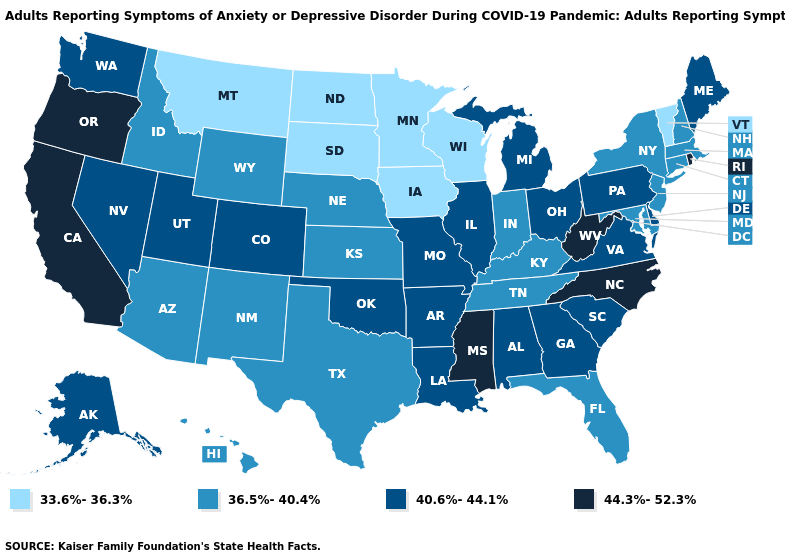Among the states that border Maryland , does West Virginia have the highest value?
Give a very brief answer. Yes. What is the highest value in the MidWest ?
Short answer required. 40.6%-44.1%. Name the states that have a value in the range 33.6%-36.3%?
Be succinct. Iowa, Minnesota, Montana, North Dakota, South Dakota, Vermont, Wisconsin. Does the first symbol in the legend represent the smallest category?
Quick response, please. Yes. Does Oregon have the highest value in the USA?
Concise answer only. Yes. Does Florida have the same value as Illinois?
Answer briefly. No. Which states have the highest value in the USA?
Give a very brief answer. California, Mississippi, North Carolina, Oregon, Rhode Island, West Virginia. Name the states that have a value in the range 40.6%-44.1%?
Write a very short answer. Alabama, Alaska, Arkansas, Colorado, Delaware, Georgia, Illinois, Louisiana, Maine, Michigan, Missouri, Nevada, Ohio, Oklahoma, Pennsylvania, South Carolina, Utah, Virginia, Washington. What is the highest value in the USA?
Quick response, please. 44.3%-52.3%. Among the states that border Maryland , which have the highest value?
Give a very brief answer. West Virginia. Does Minnesota have the lowest value in the USA?
Short answer required. Yes. What is the lowest value in the West?
Short answer required. 33.6%-36.3%. What is the lowest value in the MidWest?
Give a very brief answer. 33.6%-36.3%. Among the states that border South Carolina , does Georgia have the lowest value?
Keep it brief. Yes. How many symbols are there in the legend?
Quick response, please. 4. 